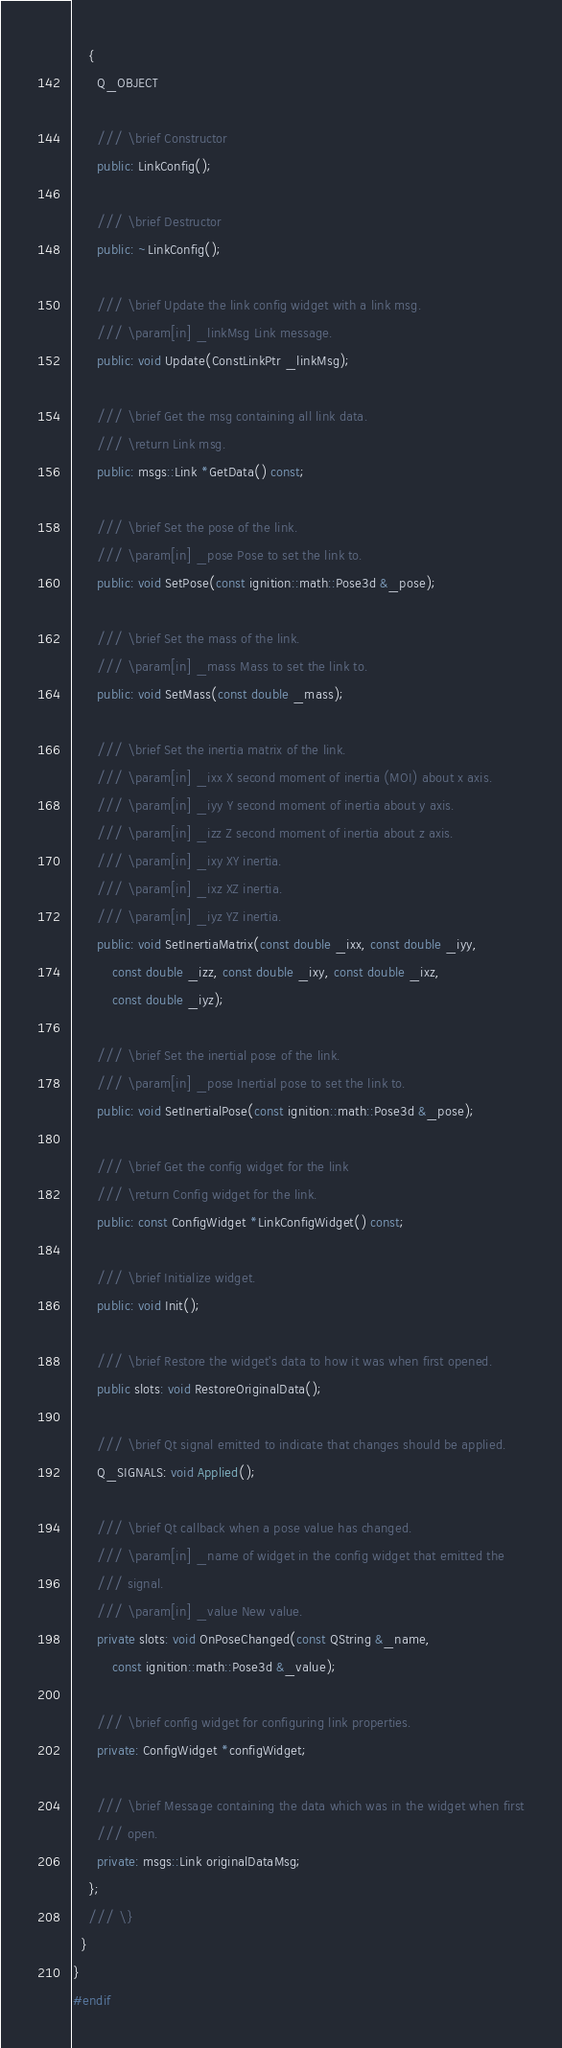Convert code to text. <code><loc_0><loc_0><loc_500><loc_500><_C++_>    {
      Q_OBJECT

      /// \brief Constructor
      public: LinkConfig();

      /// \brief Destructor
      public: ~LinkConfig();

      /// \brief Update the link config widget with a link msg.
      /// \param[in] _linkMsg Link message.
      public: void Update(ConstLinkPtr _linkMsg);

      /// \brief Get the msg containing all link data.
      /// \return Link msg.
      public: msgs::Link *GetData() const;

      /// \brief Set the pose of the link.
      /// \param[in] _pose Pose to set the link to.
      public: void SetPose(const ignition::math::Pose3d &_pose);

      /// \brief Set the mass of the link.
      /// \param[in] _mass Mass to set the link to.
      public: void SetMass(const double _mass);

      /// \brief Set the inertia matrix of the link.
      /// \param[in] _ixx X second moment of inertia (MOI) about x axis.
      /// \param[in] _iyy Y second moment of inertia about y axis.
      /// \param[in] _izz Z second moment of inertia about z axis.
      /// \param[in] _ixy XY inertia.
      /// \param[in] _ixz XZ inertia.
      /// \param[in] _iyz YZ inertia.
      public: void SetInertiaMatrix(const double _ixx, const double _iyy,
          const double _izz, const double _ixy, const double _ixz,
          const double _iyz);

      /// \brief Set the inertial pose of the link.
      /// \param[in] _pose Inertial pose to set the link to.
      public: void SetInertialPose(const ignition::math::Pose3d &_pose);

      /// \brief Get the config widget for the link
      /// \return Config widget for the link.
      public: const ConfigWidget *LinkConfigWidget() const;

      /// \brief Initialize widget.
      public: void Init();

      /// \brief Restore the widget's data to how it was when first opened.
      public slots: void RestoreOriginalData();

      /// \brief Qt signal emitted to indicate that changes should be applied.
      Q_SIGNALS: void Applied();

      /// \brief Qt callback when a pose value has changed.
      /// \param[in] _name of widget in the config widget that emitted the
      /// signal.
      /// \param[in] _value New value.
      private slots: void OnPoseChanged(const QString &_name,
          const ignition::math::Pose3d &_value);

      /// \brief config widget for configuring link properties.
      private: ConfigWidget *configWidget;

      /// \brief Message containing the data which was in the widget when first
      /// open.
      private: msgs::Link originalDataMsg;
    };
    /// \}
  }
}
#endif
</code> 